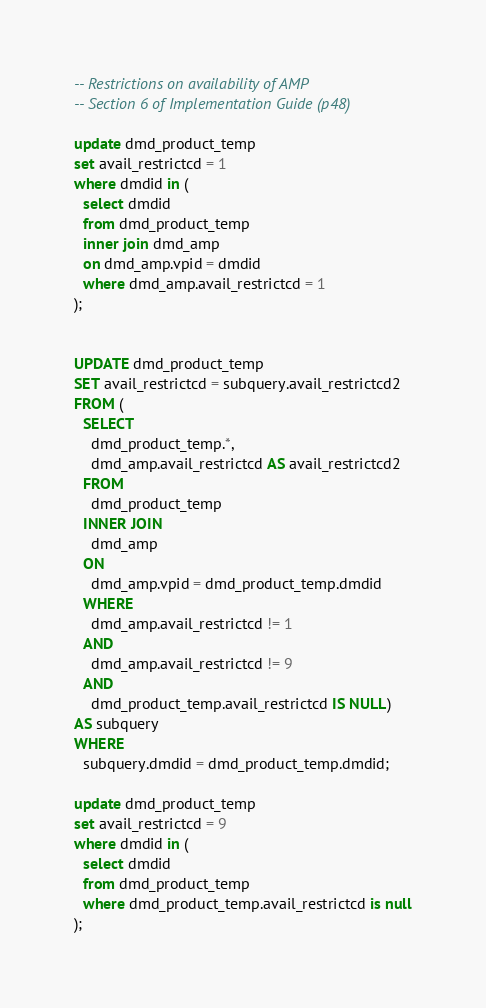Convert code to text. <code><loc_0><loc_0><loc_500><loc_500><_SQL_>-- Restrictions on availability of AMP
-- Section 6 of Implementation Guide (p48)

update dmd_product_temp
set avail_restrictcd = 1
where dmdid in (
  select dmdid
  from dmd_product_temp
  inner join dmd_amp
  on dmd_amp.vpid = dmdid
  where dmd_amp.avail_restrictcd = 1
);


UPDATE dmd_product_temp
SET avail_restrictcd = subquery.avail_restrictcd2
FROM (
  SELECT
    dmd_product_temp.*,
    dmd_amp.avail_restrictcd AS avail_restrictcd2
  FROM
    dmd_product_temp
  INNER JOIN
    dmd_amp
  ON
    dmd_amp.vpid = dmd_product_temp.dmdid
  WHERE
    dmd_amp.avail_restrictcd != 1
  AND
    dmd_amp.avail_restrictcd != 9
  AND
    dmd_product_temp.avail_restrictcd IS NULL)
AS subquery
WHERE
  subquery.dmdid = dmd_product_temp.dmdid;

update dmd_product_temp
set avail_restrictcd = 9
where dmdid in (
  select dmdid
  from dmd_product_temp
  where dmd_product_temp.avail_restrictcd is null
);
</code> 